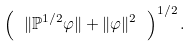Convert formula to latex. <formula><loc_0><loc_0><loc_500><loc_500>\left ( \ \| \mathbb { P } ^ { 1 / 2 } \varphi \| + \| \varphi \| ^ { 2 } \ \right ) ^ { 1 / 2 } .</formula> 